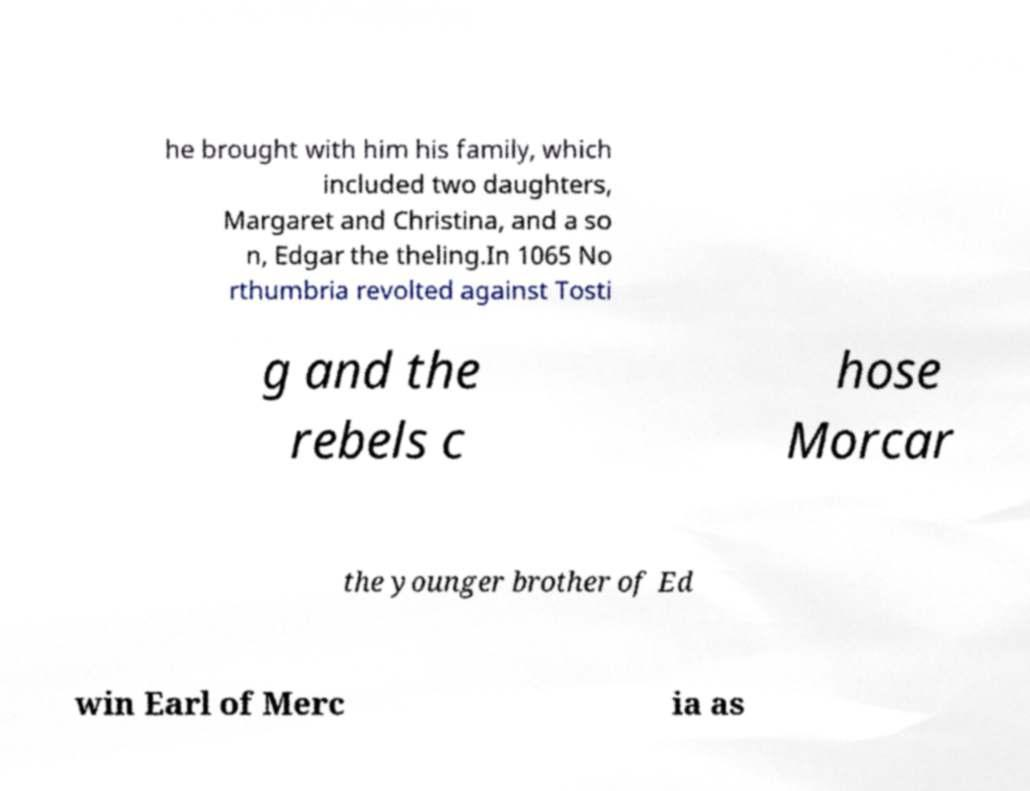Please identify and transcribe the text found in this image. he brought with him his family, which included two daughters, Margaret and Christina, and a so n, Edgar the theling.In 1065 No rthumbria revolted against Tosti g and the rebels c hose Morcar the younger brother of Ed win Earl of Merc ia as 